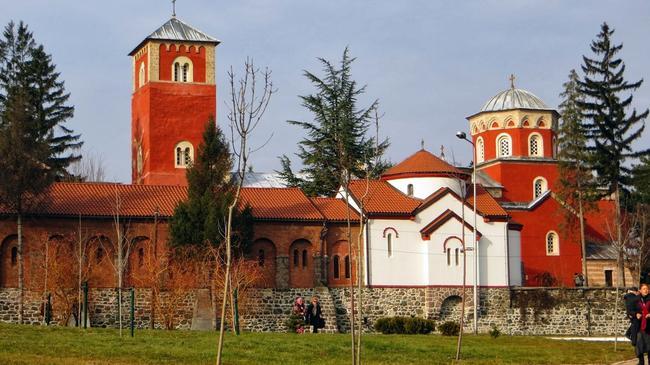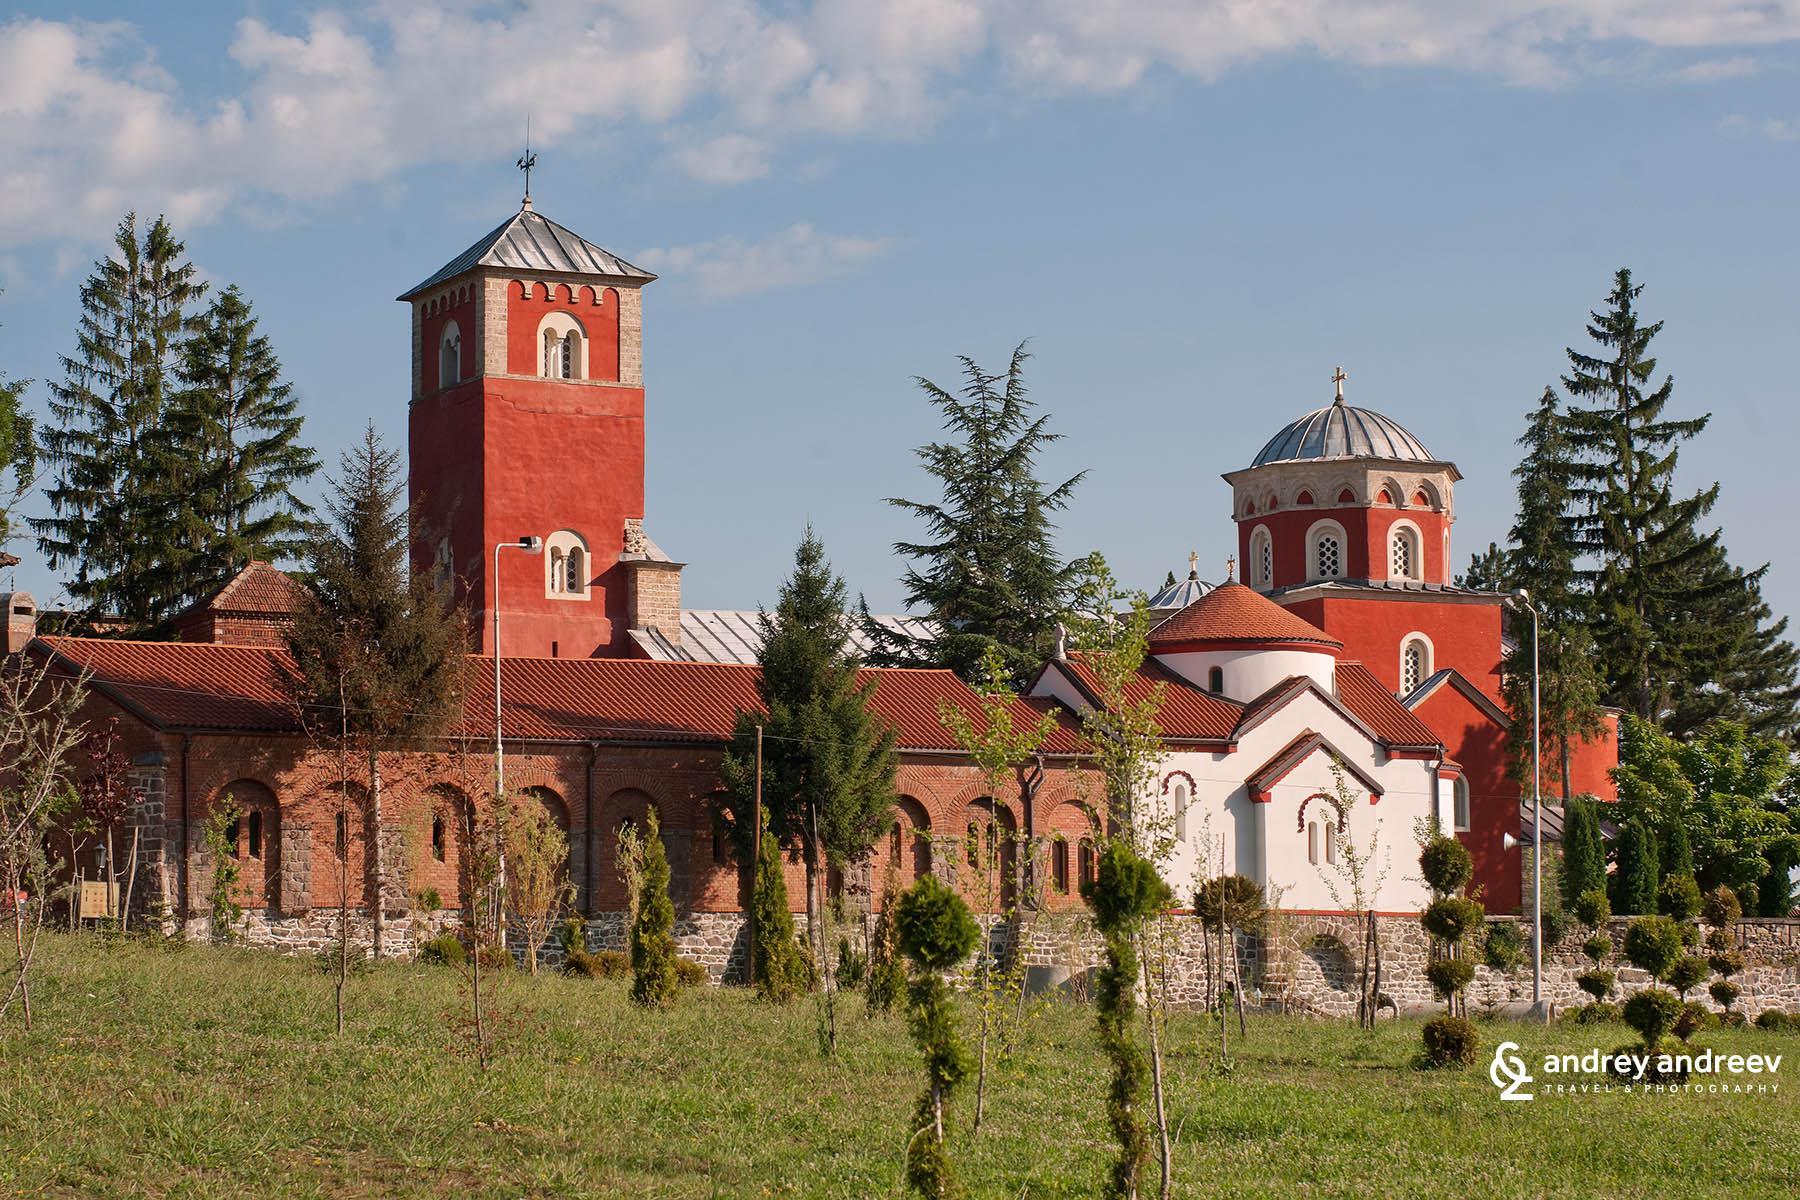The first image is the image on the left, the second image is the image on the right. Considering the images on both sides, is "Left image shows sprawling architecture with an orange domed semi-cylinder flanked by peak-roofed brown structures facing the camera." valid? Answer yes or no. No. 